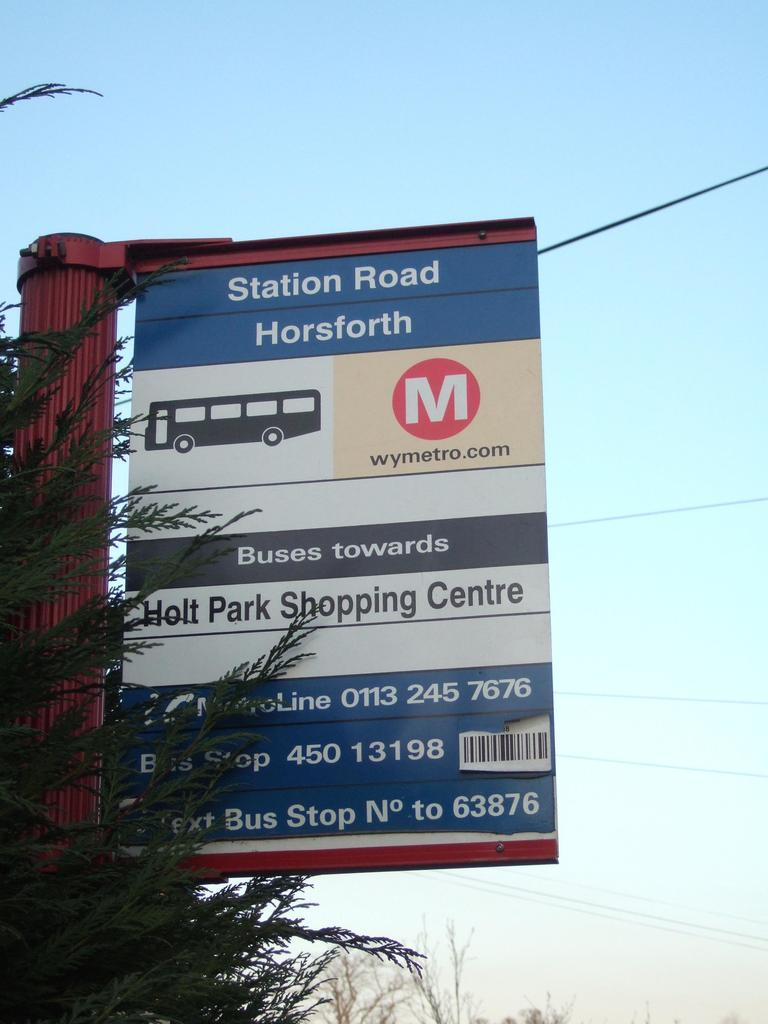<image>
Provide a brief description of the given image. A transportation sign has information for buses going to Holt Park Shopping Centre. 